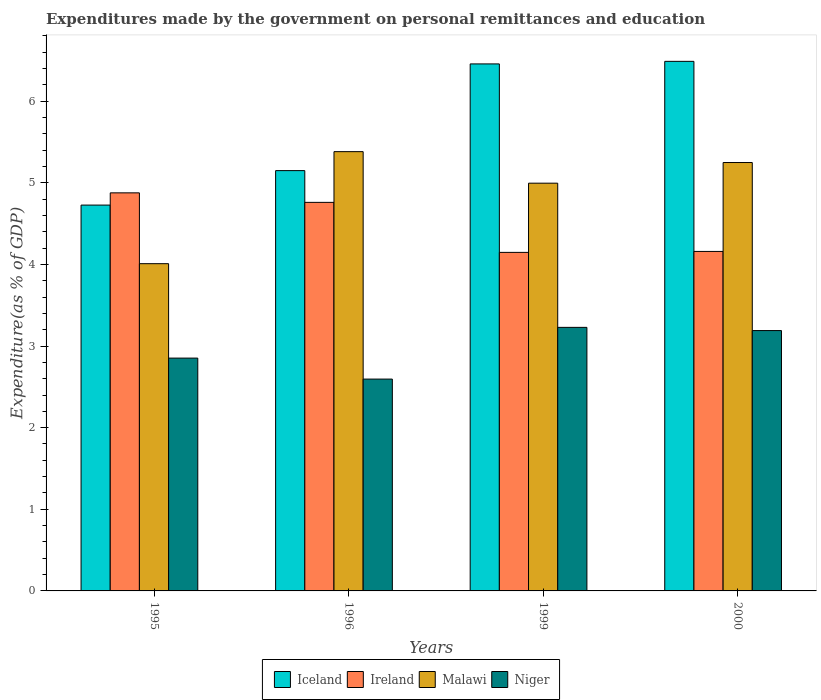Are the number of bars per tick equal to the number of legend labels?
Offer a terse response. Yes. How many bars are there on the 3rd tick from the left?
Offer a terse response. 4. How many bars are there on the 4th tick from the right?
Make the answer very short. 4. What is the label of the 3rd group of bars from the left?
Offer a terse response. 1999. In how many cases, is the number of bars for a given year not equal to the number of legend labels?
Offer a very short reply. 0. What is the expenditures made by the government on personal remittances and education in Malawi in 1999?
Your answer should be very brief. 4.99. Across all years, what is the maximum expenditures made by the government on personal remittances and education in Ireland?
Ensure brevity in your answer.  4.88. Across all years, what is the minimum expenditures made by the government on personal remittances and education in Malawi?
Keep it short and to the point. 4.01. In which year was the expenditures made by the government on personal remittances and education in Malawi minimum?
Ensure brevity in your answer.  1995. What is the total expenditures made by the government on personal remittances and education in Ireland in the graph?
Your answer should be compact. 17.94. What is the difference between the expenditures made by the government on personal remittances and education in Malawi in 1999 and that in 2000?
Offer a terse response. -0.25. What is the difference between the expenditures made by the government on personal remittances and education in Iceland in 1999 and the expenditures made by the government on personal remittances and education in Ireland in 1995?
Your answer should be compact. 1.58. What is the average expenditures made by the government on personal remittances and education in Malawi per year?
Provide a short and direct response. 4.91. In the year 1999, what is the difference between the expenditures made by the government on personal remittances and education in Ireland and expenditures made by the government on personal remittances and education in Niger?
Keep it short and to the point. 0.92. What is the ratio of the expenditures made by the government on personal remittances and education in Iceland in 1995 to that in 2000?
Provide a succinct answer. 0.73. Is the expenditures made by the government on personal remittances and education in Niger in 1999 less than that in 2000?
Your answer should be compact. No. Is the difference between the expenditures made by the government on personal remittances and education in Ireland in 1995 and 2000 greater than the difference between the expenditures made by the government on personal remittances and education in Niger in 1995 and 2000?
Offer a terse response. Yes. What is the difference between the highest and the second highest expenditures made by the government on personal remittances and education in Niger?
Your answer should be very brief. 0.04. What is the difference between the highest and the lowest expenditures made by the government on personal remittances and education in Iceland?
Ensure brevity in your answer.  1.76. In how many years, is the expenditures made by the government on personal remittances and education in Malawi greater than the average expenditures made by the government on personal remittances and education in Malawi taken over all years?
Ensure brevity in your answer.  3. Is the sum of the expenditures made by the government on personal remittances and education in Iceland in 1996 and 1999 greater than the maximum expenditures made by the government on personal remittances and education in Ireland across all years?
Offer a terse response. Yes. What does the 4th bar from the left in 1995 represents?
Provide a short and direct response. Niger. What does the 1st bar from the right in 1995 represents?
Keep it short and to the point. Niger. How many bars are there?
Give a very brief answer. 16. Are all the bars in the graph horizontal?
Your answer should be very brief. No. Does the graph contain grids?
Offer a terse response. No. Where does the legend appear in the graph?
Offer a terse response. Bottom center. What is the title of the graph?
Make the answer very short. Expenditures made by the government on personal remittances and education. What is the label or title of the Y-axis?
Make the answer very short. Expenditure(as % of GDP). What is the Expenditure(as % of GDP) of Iceland in 1995?
Your answer should be very brief. 4.73. What is the Expenditure(as % of GDP) of Ireland in 1995?
Offer a very short reply. 4.88. What is the Expenditure(as % of GDP) of Malawi in 1995?
Give a very brief answer. 4.01. What is the Expenditure(as % of GDP) in Niger in 1995?
Ensure brevity in your answer.  2.85. What is the Expenditure(as % of GDP) of Iceland in 1996?
Your response must be concise. 5.15. What is the Expenditure(as % of GDP) in Ireland in 1996?
Provide a short and direct response. 4.76. What is the Expenditure(as % of GDP) of Malawi in 1996?
Your answer should be compact. 5.38. What is the Expenditure(as % of GDP) in Niger in 1996?
Ensure brevity in your answer.  2.59. What is the Expenditure(as % of GDP) in Iceland in 1999?
Offer a terse response. 6.46. What is the Expenditure(as % of GDP) in Ireland in 1999?
Ensure brevity in your answer.  4.15. What is the Expenditure(as % of GDP) of Malawi in 1999?
Give a very brief answer. 4.99. What is the Expenditure(as % of GDP) in Niger in 1999?
Your answer should be very brief. 3.23. What is the Expenditure(as % of GDP) of Iceland in 2000?
Offer a very short reply. 6.49. What is the Expenditure(as % of GDP) in Ireland in 2000?
Ensure brevity in your answer.  4.16. What is the Expenditure(as % of GDP) in Malawi in 2000?
Keep it short and to the point. 5.25. What is the Expenditure(as % of GDP) in Niger in 2000?
Offer a very short reply. 3.19. Across all years, what is the maximum Expenditure(as % of GDP) in Iceland?
Make the answer very short. 6.49. Across all years, what is the maximum Expenditure(as % of GDP) of Ireland?
Your response must be concise. 4.88. Across all years, what is the maximum Expenditure(as % of GDP) of Malawi?
Provide a succinct answer. 5.38. Across all years, what is the maximum Expenditure(as % of GDP) of Niger?
Offer a very short reply. 3.23. Across all years, what is the minimum Expenditure(as % of GDP) in Iceland?
Make the answer very short. 4.73. Across all years, what is the minimum Expenditure(as % of GDP) in Ireland?
Provide a succinct answer. 4.15. Across all years, what is the minimum Expenditure(as % of GDP) in Malawi?
Provide a short and direct response. 4.01. Across all years, what is the minimum Expenditure(as % of GDP) of Niger?
Provide a short and direct response. 2.59. What is the total Expenditure(as % of GDP) in Iceland in the graph?
Offer a very short reply. 22.82. What is the total Expenditure(as % of GDP) in Ireland in the graph?
Your response must be concise. 17.94. What is the total Expenditure(as % of GDP) of Malawi in the graph?
Provide a succinct answer. 19.63. What is the total Expenditure(as % of GDP) in Niger in the graph?
Offer a terse response. 11.87. What is the difference between the Expenditure(as % of GDP) in Iceland in 1995 and that in 1996?
Your answer should be very brief. -0.42. What is the difference between the Expenditure(as % of GDP) of Ireland in 1995 and that in 1996?
Provide a short and direct response. 0.12. What is the difference between the Expenditure(as % of GDP) of Malawi in 1995 and that in 1996?
Your response must be concise. -1.37. What is the difference between the Expenditure(as % of GDP) in Niger in 1995 and that in 1996?
Provide a succinct answer. 0.26. What is the difference between the Expenditure(as % of GDP) in Iceland in 1995 and that in 1999?
Your answer should be very brief. -1.73. What is the difference between the Expenditure(as % of GDP) in Ireland in 1995 and that in 1999?
Your response must be concise. 0.73. What is the difference between the Expenditure(as % of GDP) in Malawi in 1995 and that in 1999?
Keep it short and to the point. -0.99. What is the difference between the Expenditure(as % of GDP) in Niger in 1995 and that in 1999?
Your answer should be very brief. -0.38. What is the difference between the Expenditure(as % of GDP) of Iceland in 1995 and that in 2000?
Provide a short and direct response. -1.76. What is the difference between the Expenditure(as % of GDP) in Ireland in 1995 and that in 2000?
Provide a succinct answer. 0.72. What is the difference between the Expenditure(as % of GDP) in Malawi in 1995 and that in 2000?
Offer a terse response. -1.24. What is the difference between the Expenditure(as % of GDP) in Niger in 1995 and that in 2000?
Your answer should be compact. -0.34. What is the difference between the Expenditure(as % of GDP) in Iceland in 1996 and that in 1999?
Provide a succinct answer. -1.31. What is the difference between the Expenditure(as % of GDP) in Ireland in 1996 and that in 1999?
Your response must be concise. 0.61. What is the difference between the Expenditure(as % of GDP) of Malawi in 1996 and that in 1999?
Offer a terse response. 0.39. What is the difference between the Expenditure(as % of GDP) of Niger in 1996 and that in 1999?
Your answer should be compact. -0.63. What is the difference between the Expenditure(as % of GDP) of Iceland in 1996 and that in 2000?
Give a very brief answer. -1.34. What is the difference between the Expenditure(as % of GDP) in Ireland in 1996 and that in 2000?
Provide a succinct answer. 0.6. What is the difference between the Expenditure(as % of GDP) of Malawi in 1996 and that in 2000?
Keep it short and to the point. 0.13. What is the difference between the Expenditure(as % of GDP) in Niger in 1996 and that in 2000?
Ensure brevity in your answer.  -0.59. What is the difference between the Expenditure(as % of GDP) in Iceland in 1999 and that in 2000?
Provide a succinct answer. -0.03. What is the difference between the Expenditure(as % of GDP) in Ireland in 1999 and that in 2000?
Make the answer very short. -0.01. What is the difference between the Expenditure(as % of GDP) of Malawi in 1999 and that in 2000?
Keep it short and to the point. -0.25. What is the difference between the Expenditure(as % of GDP) in Niger in 1999 and that in 2000?
Your response must be concise. 0.04. What is the difference between the Expenditure(as % of GDP) of Iceland in 1995 and the Expenditure(as % of GDP) of Ireland in 1996?
Provide a short and direct response. -0.03. What is the difference between the Expenditure(as % of GDP) in Iceland in 1995 and the Expenditure(as % of GDP) in Malawi in 1996?
Ensure brevity in your answer.  -0.65. What is the difference between the Expenditure(as % of GDP) in Iceland in 1995 and the Expenditure(as % of GDP) in Niger in 1996?
Keep it short and to the point. 2.13. What is the difference between the Expenditure(as % of GDP) of Ireland in 1995 and the Expenditure(as % of GDP) of Malawi in 1996?
Your response must be concise. -0.5. What is the difference between the Expenditure(as % of GDP) in Ireland in 1995 and the Expenditure(as % of GDP) in Niger in 1996?
Offer a very short reply. 2.28. What is the difference between the Expenditure(as % of GDP) in Malawi in 1995 and the Expenditure(as % of GDP) in Niger in 1996?
Give a very brief answer. 1.41. What is the difference between the Expenditure(as % of GDP) of Iceland in 1995 and the Expenditure(as % of GDP) of Ireland in 1999?
Provide a succinct answer. 0.58. What is the difference between the Expenditure(as % of GDP) in Iceland in 1995 and the Expenditure(as % of GDP) in Malawi in 1999?
Offer a very short reply. -0.27. What is the difference between the Expenditure(as % of GDP) in Iceland in 1995 and the Expenditure(as % of GDP) in Niger in 1999?
Give a very brief answer. 1.5. What is the difference between the Expenditure(as % of GDP) of Ireland in 1995 and the Expenditure(as % of GDP) of Malawi in 1999?
Offer a terse response. -0.12. What is the difference between the Expenditure(as % of GDP) in Ireland in 1995 and the Expenditure(as % of GDP) in Niger in 1999?
Offer a very short reply. 1.65. What is the difference between the Expenditure(as % of GDP) of Malawi in 1995 and the Expenditure(as % of GDP) of Niger in 1999?
Your answer should be very brief. 0.78. What is the difference between the Expenditure(as % of GDP) of Iceland in 1995 and the Expenditure(as % of GDP) of Ireland in 2000?
Provide a succinct answer. 0.57. What is the difference between the Expenditure(as % of GDP) in Iceland in 1995 and the Expenditure(as % of GDP) in Malawi in 2000?
Ensure brevity in your answer.  -0.52. What is the difference between the Expenditure(as % of GDP) in Iceland in 1995 and the Expenditure(as % of GDP) in Niger in 2000?
Your answer should be very brief. 1.54. What is the difference between the Expenditure(as % of GDP) of Ireland in 1995 and the Expenditure(as % of GDP) of Malawi in 2000?
Provide a succinct answer. -0.37. What is the difference between the Expenditure(as % of GDP) of Ireland in 1995 and the Expenditure(as % of GDP) of Niger in 2000?
Give a very brief answer. 1.69. What is the difference between the Expenditure(as % of GDP) of Malawi in 1995 and the Expenditure(as % of GDP) of Niger in 2000?
Make the answer very short. 0.82. What is the difference between the Expenditure(as % of GDP) of Iceland in 1996 and the Expenditure(as % of GDP) of Ireland in 1999?
Make the answer very short. 1. What is the difference between the Expenditure(as % of GDP) of Iceland in 1996 and the Expenditure(as % of GDP) of Malawi in 1999?
Offer a terse response. 0.15. What is the difference between the Expenditure(as % of GDP) in Iceland in 1996 and the Expenditure(as % of GDP) in Niger in 1999?
Provide a succinct answer. 1.92. What is the difference between the Expenditure(as % of GDP) of Ireland in 1996 and the Expenditure(as % of GDP) of Malawi in 1999?
Provide a succinct answer. -0.23. What is the difference between the Expenditure(as % of GDP) in Ireland in 1996 and the Expenditure(as % of GDP) in Niger in 1999?
Your answer should be compact. 1.53. What is the difference between the Expenditure(as % of GDP) in Malawi in 1996 and the Expenditure(as % of GDP) in Niger in 1999?
Provide a succinct answer. 2.15. What is the difference between the Expenditure(as % of GDP) in Iceland in 1996 and the Expenditure(as % of GDP) in Ireland in 2000?
Offer a terse response. 0.99. What is the difference between the Expenditure(as % of GDP) of Iceland in 1996 and the Expenditure(as % of GDP) of Malawi in 2000?
Provide a succinct answer. -0.1. What is the difference between the Expenditure(as % of GDP) of Iceland in 1996 and the Expenditure(as % of GDP) of Niger in 2000?
Your answer should be compact. 1.96. What is the difference between the Expenditure(as % of GDP) in Ireland in 1996 and the Expenditure(as % of GDP) in Malawi in 2000?
Your answer should be very brief. -0.49. What is the difference between the Expenditure(as % of GDP) of Ireland in 1996 and the Expenditure(as % of GDP) of Niger in 2000?
Provide a short and direct response. 1.57. What is the difference between the Expenditure(as % of GDP) in Malawi in 1996 and the Expenditure(as % of GDP) in Niger in 2000?
Your answer should be very brief. 2.19. What is the difference between the Expenditure(as % of GDP) in Iceland in 1999 and the Expenditure(as % of GDP) in Ireland in 2000?
Your response must be concise. 2.3. What is the difference between the Expenditure(as % of GDP) in Iceland in 1999 and the Expenditure(as % of GDP) in Malawi in 2000?
Keep it short and to the point. 1.21. What is the difference between the Expenditure(as % of GDP) of Iceland in 1999 and the Expenditure(as % of GDP) of Niger in 2000?
Make the answer very short. 3.27. What is the difference between the Expenditure(as % of GDP) in Ireland in 1999 and the Expenditure(as % of GDP) in Malawi in 2000?
Provide a short and direct response. -1.1. What is the difference between the Expenditure(as % of GDP) of Ireland in 1999 and the Expenditure(as % of GDP) of Niger in 2000?
Your answer should be compact. 0.96. What is the difference between the Expenditure(as % of GDP) in Malawi in 1999 and the Expenditure(as % of GDP) in Niger in 2000?
Make the answer very short. 1.81. What is the average Expenditure(as % of GDP) of Iceland per year?
Ensure brevity in your answer.  5.7. What is the average Expenditure(as % of GDP) of Ireland per year?
Give a very brief answer. 4.49. What is the average Expenditure(as % of GDP) in Malawi per year?
Keep it short and to the point. 4.91. What is the average Expenditure(as % of GDP) of Niger per year?
Provide a short and direct response. 2.97. In the year 1995, what is the difference between the Expenditure(as % of GDP) of Iceland and Expenditure(as % of GDP) of Ireland?
Offer a very short reply. -0.15. In the year 1995, what is the difference between the Expenditure(as % of GDP) of Iceland and Expenditure(as % of GDP) of Malawi?
Offer a very short reply. 0.72. In the year 1995, what is the difference between the Expenditure(as % of GDP) in Iceland and Expenditure(as % of GDP) in Niger?
Give a very brief answer. 1.87. In the year 1995, what is the difference between the Expenditure(as % of GDP) of Ireland and Expenditure(as % of GDP) of Malawi?
Your answer should be compact. 0.87. In the year 1995, what is the difference between the Expenditure(as % of GDP) of Ireland and Expenditure(as % of GDP) of Niger?
Offer a very short reply. 2.02. In the year 1995, what is the difference between the Expenditure(as % of GDP) of Malawi and Expenditure(as % of GDP) of Niger?
Give a very brief answer. 1.16. In the year 1996, what is the difference between the Expenditure(as % of GDP) in Iceland and Expenditure(as % of GDP) in Ireland?
Your answer should be very brief. 0.39. In the year 1996, what is the difference between the Expenditure(as % of GDP) of Iceland and Expenditure(as % of GDP) of Malawi?
Your response must be concise. -0.23. In the year 1996, what is the difference between the Expenditure(as % of GDP) of Iceland and Expenditure(as % of GDP) of Niger?
Ensure brevity in your answer.  2.55. In the year 1996, what is the difference between the Expenditure(as % of GDP) in Ireland and Expenditure(as % of GDP) in Malawi?
Provide a succinct answer. -0.62. In the year 1996, what is the difference between the Expenditure(as % of GDP) in Ireland and Expenditure(as % of GDP) in Niger?
Your answer should be very brief. 2.16. In the year 1996, what is the difference between the Expenditure(as % of GDP) in Malawi and Expenditure(as % of GDP) in Niger?
Give a very brief answer. 2.79. In the year 1999, what is the difference between the Expenditure(as % of GDP) of Iceland and Expenditure(as % of GDP) of Ireland?
Make the answer very short. 2.31. In the year 1999, what is the difference between the Expenditure(as % of GDP) of Iceland and Expenditure(as % of GDP) of Malawi?
Ensure brevity in your answer.  1.46. In the year 1999, what is the difference between the Expenditure(as % of GDP) in Iceland and Expenditure(as % of GDP) in Niger?
Provide a short and direct response. 3.23. In the year 1999, what is the difference between the Expenditure(as % of GDP) in Ireland and Expenditure(as % of GDP) in Malawi?
Provide a succinct answer. -0.85. In the year 1999, what is the difference between the Expenditure(as % of GDP) in Ireland and Expenditure(as % of GDP) in Niger?
Provide a succinct answer. 0.92. In the year 1999, what is the difference between the Expenditure(as % of GDP) of Malawi and Expenditure(as % of GDP) of Niger?
Your answer should be very brief. 1.77. In the year 2000, what is the difference between the Expenditure(as % of GDP) of Iceland and Expenditure(as % of GDP) of Ireland?
Your answer should be compact. 2.33. In the year 2000, what is the difference between the Expenditure(as % of GDP) of Iceland and Expenditure(as % of GDP) of Malawi?
Ensure brevity in your answer.  1.24. In the year 2000, what is the difference between the Expenditure(as % of GDP) in Iceland and Expenditure(as % of GDP) in Niger?
Your answer should be very brief. 3.3. In the year 2000, what is the difference between the Expenditure(as % of GDP) in Ireland and Expenditure(as % of GDP) in Malawi?
Your response must be concise. -1.09. In the year 2000, what is the difference between the Expenditure(as % of GDP) of Ireland and Expenditure(as % of GDP) of Niger?
Your response must be concise. 0.97. In the year 2000, what is the difference between the Expenditure(as % of GDP) of Malawi and Expenditure(as % of GDP) of Niger?
Your response must be concise. 2.06. What is the ratio of the Expenditure(as % of GDP) of Iceland in 1995 to that in 1996?
Provide a succinct answer. 0.92. What is the ratio of the Expenditure(as % of GDP) in Ireland in 1995 to that in 1996?
Make the answer very short. 1.02. What is the ratio of the Expenditure(as % of GDP) in Malawi in 1995 to that in 1996?
Make the answer very short. 0.74. What is the ratio of the Expenditure(as % of GDP) of Niger in 1995 to that in 1996?
Give a very brief answer. 1.1. What is the ratio of the Expenditure(as % of GDP) of Iceland in 1995 to that in 1999?
Provide a succinct answer. 0.73. What is the ratio of the Expenditure(as % of GDP) of Ireland in 1995 to that in 1999?
Give a very brief answer. 1.18. What is the ratio of the Expenditure(as % of GDP) of Malawi in 1995 to that in 1999?
Provide a short and direct response. 0.8. What is the ratio of the Expenditure(as % of GDP) in Niger in 1995 to that in 1999?
Your answer should be compact. 0.88. What is the ratio of the Expenditure(as % of GDP) in Iceland in 1995 to that in 2000?
Keep it short and to the point. 0.73. What is the ratio of the Expenditure(as % of GDP) in Ireland in 1995 to that in 2000?
Provide a succinct answer. 1.17. What is the ratio of the Expenditure(as % of GDP) of Malawi in 1995 to that in 2000?
Give a very brief answer. 0.76. What is the ratio of the Expenditure(as % of GDP) in Niger in 1995 to that in 2000?
Offer a very short reply. 0.89. What is the ratio of the Expenditure(as % of GDP) in Iceland in 1996 to that in 1999?
Provide a short and direct response. 0.8. What is the ratio of the Expenditure(as % of GDP) of Ireland in 1996 to that in 1999?
Offer a very short reply. 1.15. What is the ratio of the Expenditure(as % of GDP) of Malawi in 1996 to that in 1999?
Your answer should be compact. 1.08. What is the ratio of the Expenditure(as % of GDP) of Niger in 1996 to that in 1999?
Give a very brief answer. 0.8. What is the ratio of the Expenditure(as % of GDP) of Iceland in 1996 to that in 2000?
Your response must be concise. 0.79. What is the ratio of the Expenditure(as % of GDP) of Ireland in 1996 to that in 2000?
Offer a terse response. 1.14. What is the ratio of the Expenditure(as % of GDP) of Malawi in 1996 to that in 2000?
Keep it short and to the point. 1.03. What is the ratio of the Expenditure(as % of GDP) of Niger in 1996 to that in 2000?
Provide a short and direct response. 0.81. What is the ratio of the Expenditure(as % of GDP) in Iceland in 1999 to that in 2000?
Your response must be concise. 1. What is the ratio of the Expenditure(as % of GDP) of Ireland in 1999 to that in 2000?
Offer a very short reply. 1. What is the ratio of the Expenditure(as % of GDP) of Malawi in 1999 to that in 2000?
Your answer should be compact. 0.95. What is the ratio of the Expenditure(as % of GDP) in Niger in 1999 to that in 2000?
Your response must be concise. 1.01. What is the difference between the highest and the second highest Expenditure(as % of GDP) of Iceland?
Your answer should be compact. 0.03. What is the difference between the highest and the second highest Expenditure(as % of GDP) in Ireland?
Keep it short and to the point. 0.12. What is the difference between the highest and the second highest Expenditure(as % of GDP) of Malawi?
Your answer should be very brief. 0.13. What is the difference between the highest and the second highest Expenditure(as % of GDP) of Niger?
Provide a succinct answer. 0.04. What is the difference between the highest and the lowest Expenditure(as % of GDP) of Iceland?
Offer a very short reply. 1.76. What is the difference between the highest and the lowest Expenditure(as % of GDP) in Ireland?
Give a very brief answer. 0.73. What is the difference between the highest and the lowest Expenditure(as % of GDP) in Malawi?
Your answer should be compact. 1.37. What is the difference between the highest and the lowest Expenditure(as % of GDP) of Niger?
Your response must be concise. 0.63. 